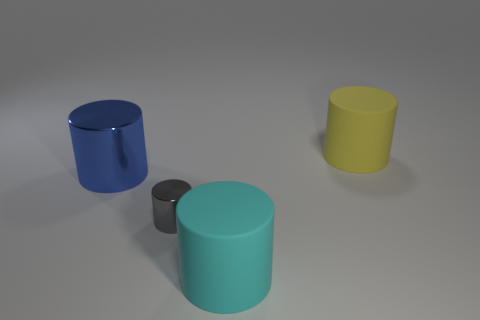Add 1 tiny shiny cylinders. How many objects exist? 5 Subtract 0 green cylinders. How many objects are left? 4 Subtract all small red metal cylinders. Subtract all cyan matte things. How many objects are left? 3 Add 1 big yellow matte cylinders. How many big yellow matte cylinders are left? 2 Add 2 matte balls. How many matte balls exist? 2 